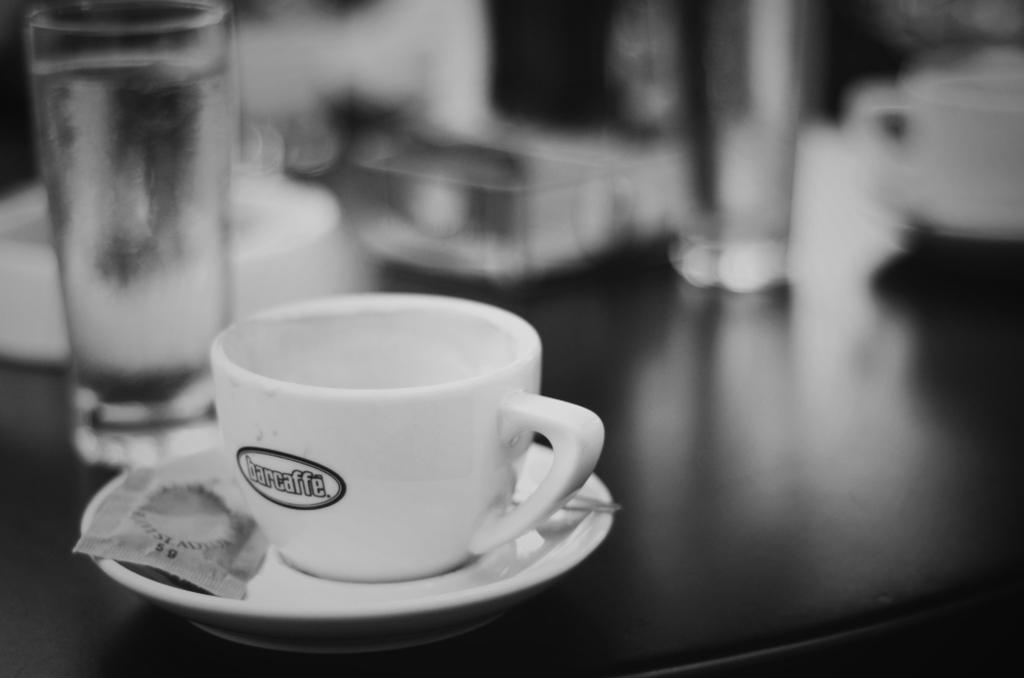What is placed on the table in the image? There is a cup and saucer, a sachet, and two glasses on the table. What is on the cup and saucer? There is a sachet on the cup and saucer. How many cups can be seen in the image? There is one cup on the right side of the image. What else is present on the table besides the cup and saucer? There are two glasses on the table. What type of hook is attached to the cup in the image? There is no hook attached to the cup in the image; it is a regular cup and saucer set. Was the sachet an afterthought when setting up the table in the image? There is no information provided about the sachet being an afterthought or not; it is simply present on the cup and saucer. 